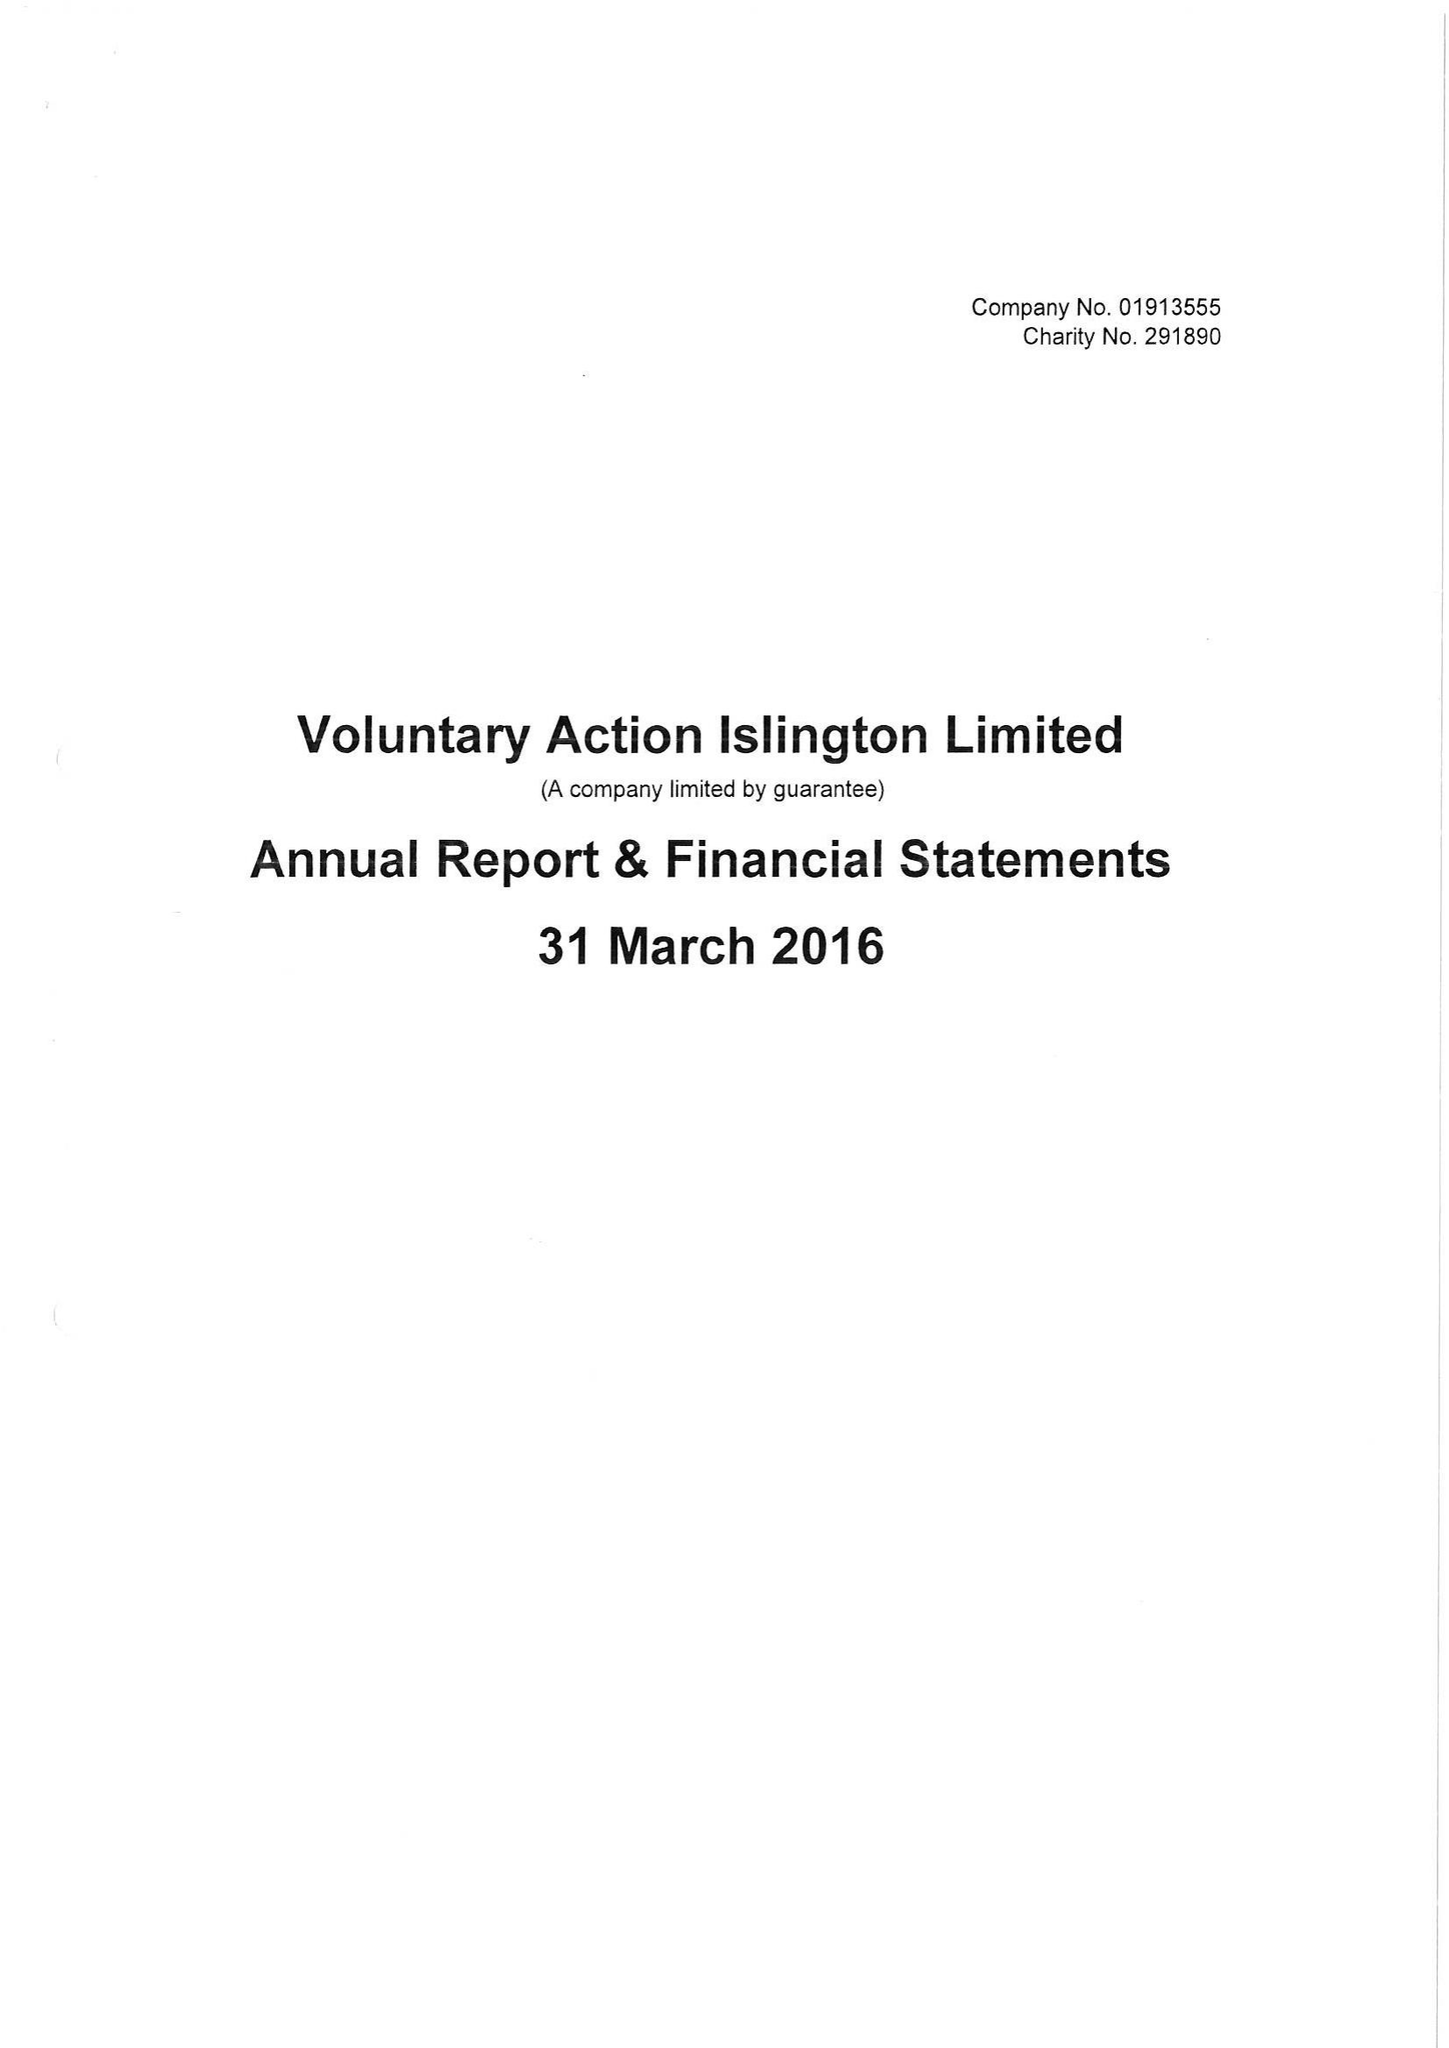What is the value for the address__postcode?
Answer the question using a single word or phrase. N1 9JP 